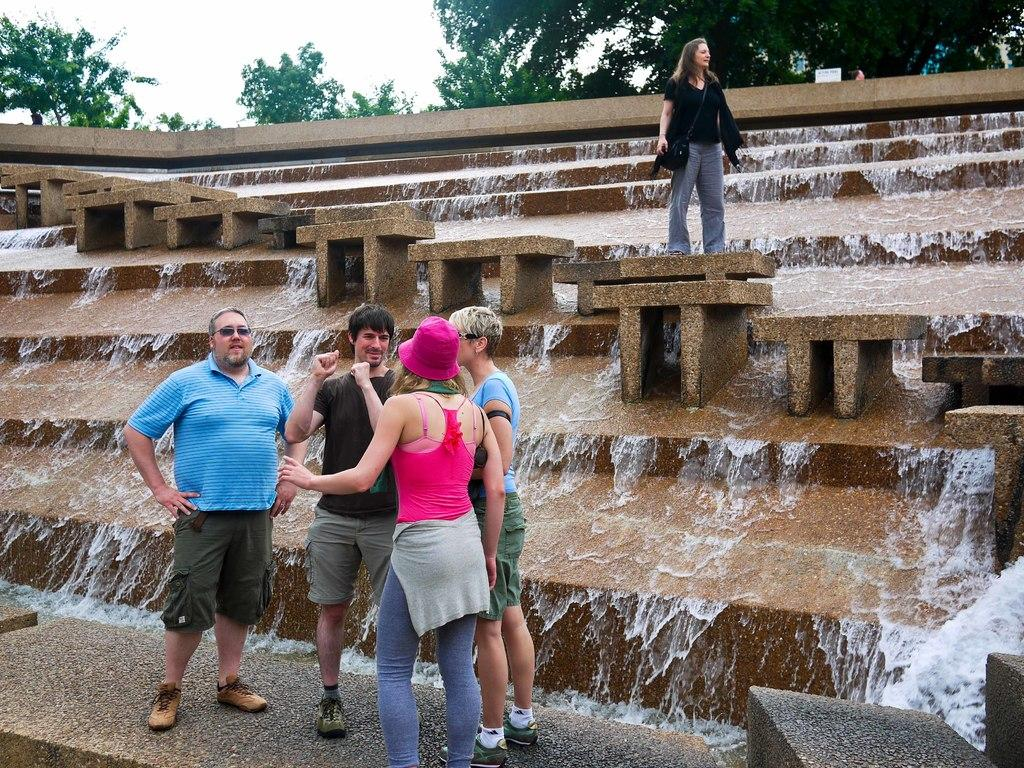How many people are in the image? There is a group of people standing in the image. What can be seen in the image besides the people? There are steps and a fountain in the image. What is visible in the background of the image? There are trees and the sky visible in the background of the image. What time of day is it in the image, considering the hour the squirrel is active? There is no squirrel present in the image, so it is not possible to determine the time of day based on its activity. 